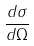<formula> <loc_0><loc_0><loc_500><loc_500>\frac { d \sigma } { d \Omega }</formula> 